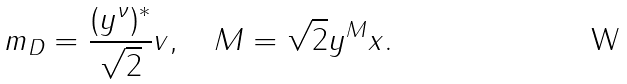<formula> <loc_0><loc_0><loc_500><loc_500>m _ { D } = \frac { ( y ^ { \nu } ) ^ { * } } { \sqrt { 2 } } v , \quad M = \sqrt { 2 } y ^ { M } x .</formula> 